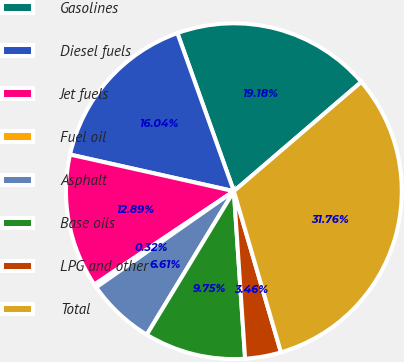Convert chart to OTSL. <chart><loc_0><loc_0><loc_500><loc_500><pie_chart><fcel>Gasolines<fcel>Diesel fuels<fcel>Jet fuels<fcel>Fuel oil<fcel>Asphalt<fcel>Base oils<fcel>LPG and other<fcel>Total<nl><fcel>19.18%<fcel>16.04%<fcel>12.89%<fcel>0.32%<fcel>6.61%<fcel>9.75%<fcel>3.46%<fcel>31.76%<nl></chart> 